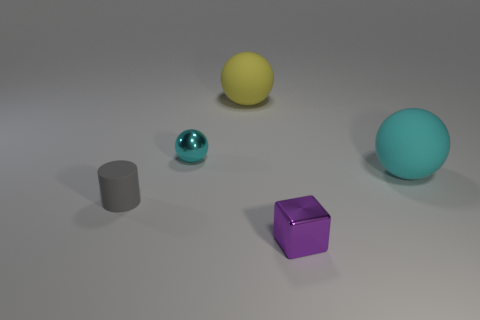Are there any other things that have the same shape as the gray rubber object?
Offer a very short reply. No. What color is the object that is the same material as the tiny purple block?
Provide a short and direct response. Cyan. Do the cyan metallic thing and the tiny gray object have the same shape?
Offer a terse response. No. How many things are both in front of the big yellow matte ball and behind the cylinder?
Your answer should be compact. 2. What number of rubber things are either yellow spheres or tiny gray objects?
Ensure brevity in your answer.  2. There is a matte object left of the cyan ball that is left of the small cube; what size is it?
Ensure brevity in your answer.  Small. Is there a small block that is behind the matte object that is to the right of the large ball behind the big cyan matte thing?
Your answer should be very brief. No. Are the cyan thing that is on the left side of the large cyan rubber thing and the cyan object right of the yellow ball made of the same material?
Your response must be concise. No. What number of objects are big yellow matte balls or things on the right side of the large yellow object?
Give a very brief answer. 3. How many tiny cyan things are the same shape as the large yellow object?
Offer a terse response. 1. 